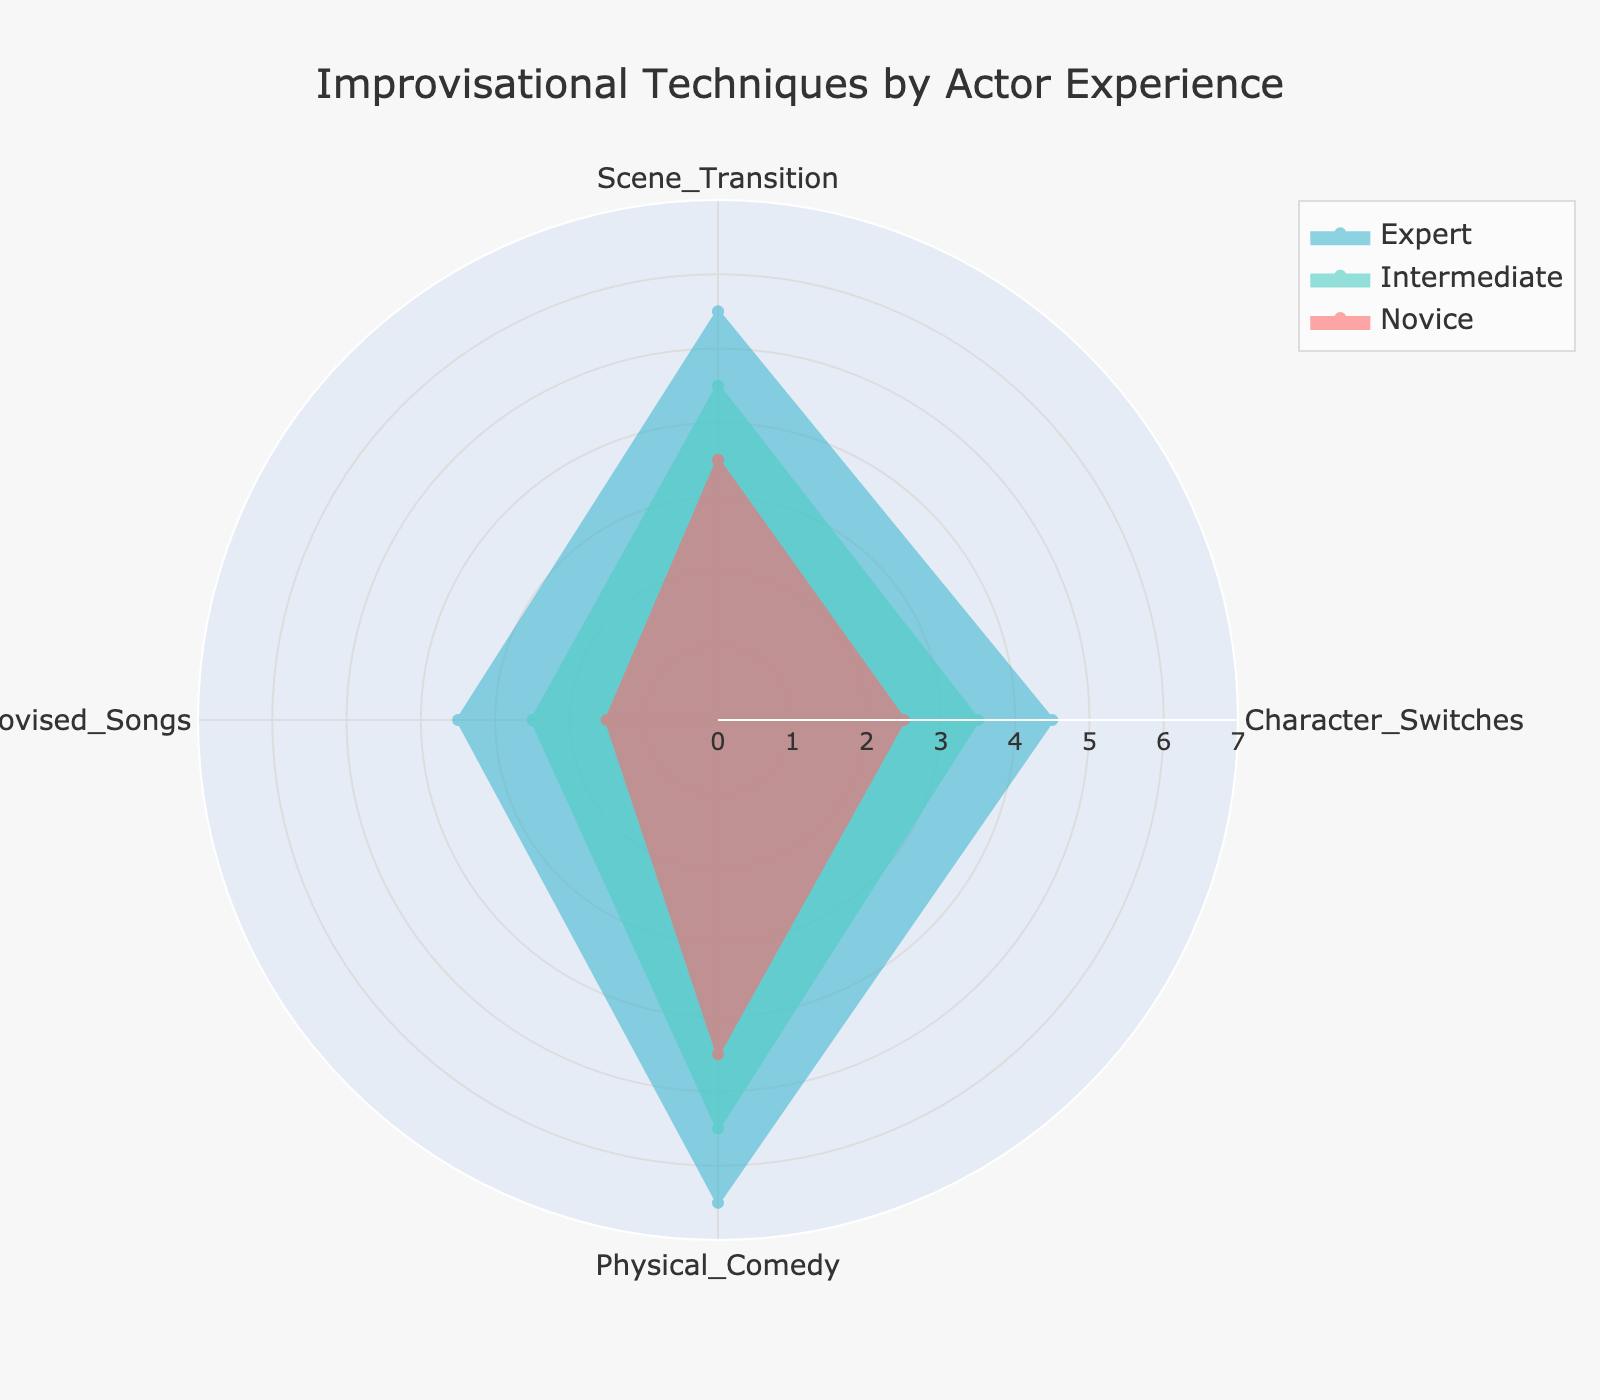How many groups of actors are represented in the radar chart? The radar chart has distinct areas for each group of actors listed under 'Actor_Experience'. By counting the different names in the legend or areas on the chart, we can determine the number of groups.
Answer: 3 Which actor experience group shows the highest value for Scene Transition? Observe the radial axis labeled 'Scene Transition' and identify the group whose line extends the furthest on this axis.
Answer: Expert Among the groups, which one has the least amount of Character Switches? Look at the radial axis labeled 'Character Switches' and see which group's polygon extends the least distance from the center.
Answer: Novice What is the average value of Physical Comedy for Intermediate actors? Identify the value for 'Physical Comedy' under the Intermediate group, listed directly on the chart, and compute the average. Since there’s only one value shown, it’s just this value.
Answer: 5.5 Compare the frequency of Improvised Songs between the Novice and Expert actor groups. Examine the 'Improvised_Songs' axis and note the values for both Novice and Expert groups. Determine which group has a higher or lower value by comparing these points.
Answer: Expert Which actor experience group has a higher overall engagement in Physical Comedy, combined Scene Transition and Character Switches metrics? Assess each group's values for 'Scene Transition', 'Character Switches', and 'Physical Comedy'. Add the values for Scene Transition and Character Switches and compare these sums with Physical Comedy values within each group.
Answer: Expert Is the High Audience Engagement always associated with Frequent Sound Effect Integration for Expert actors? To determine this, look at the legends and polygons linked to 'Expert' and check if 'High' Audience Engagement coincides with 'Frequent' Sound Effects Integration across the radar chart points for experts.
Answer: No When comparing Novice and Intermediate actors, which group shows a greater extent of variance in their Improvisational Techniques? Calculate the range (maximum - minimum) of the values for each category in the radar chart and summarize the disparities to see which group exhibits greater variations in Scene Transition, Character Switches, Physical Comedy, and Improvised Songs
Answer: Intermediate 